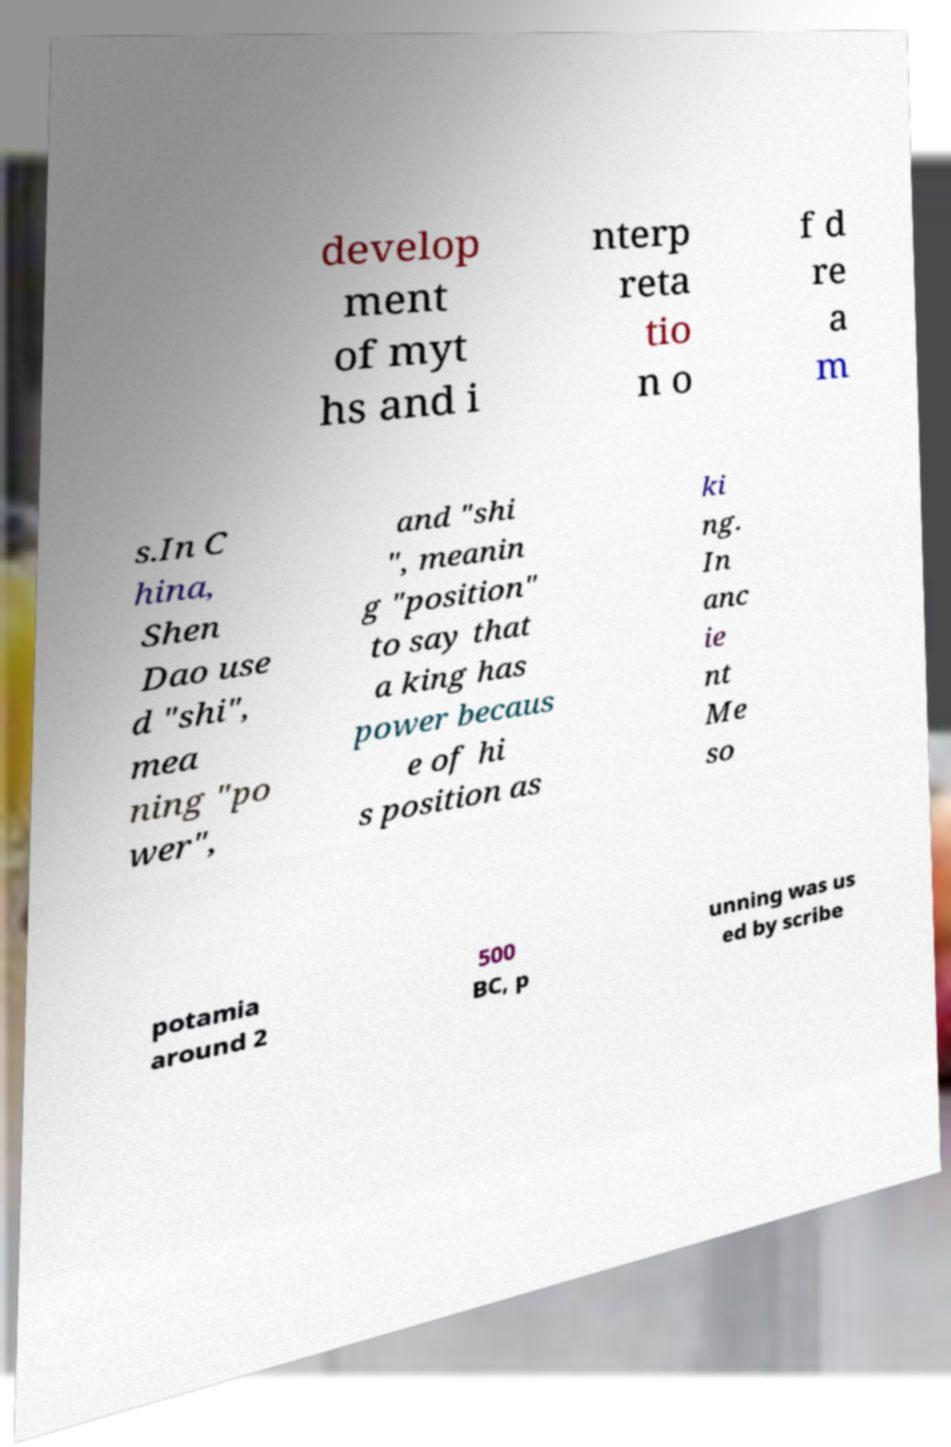There's text embedded in this image that I need extracted. Can you transcribe it verbatim? develop ment of myt hs and i nterp reta tio n o f d re a m s.In C hina, Shen Dao use d "shi", mea ning "po wer", and "shi ", meanin g "position" to say that a king has power becaus e of hi s position as ki ng. In anc ie nt Me so potamia around 2 500 BC, p unning was us ed by scribe 